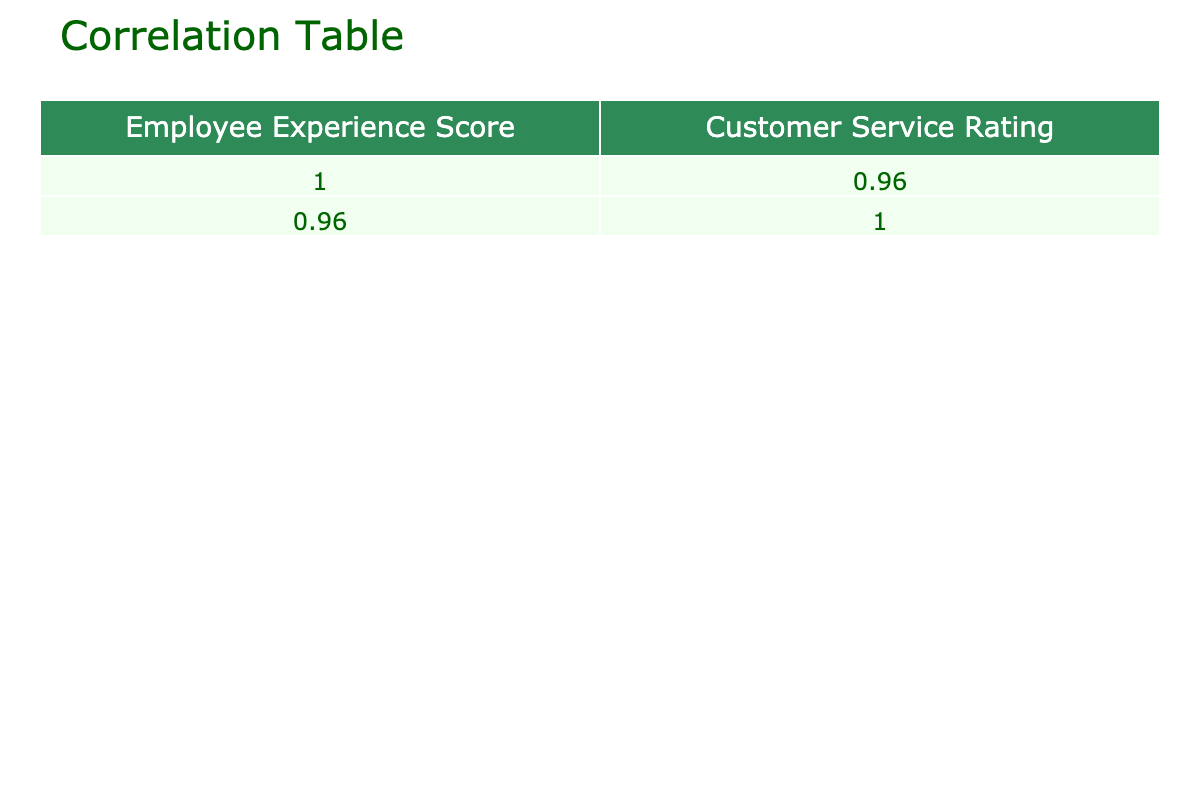What is the correlation coefficient between Employee Experience Score and Customer Service Rating? The correlation coefficient is found in the correlation matrix table. It shows how closely related the two variables are. In this case, the correlation coefficient is 0.93, indicating a very strong positive relationship.
Answer: 0.93 What is the Customer Service Rating for the employee with an Experience Score of 70? We look for 70 in the Employee Experience Score column and find the corresponding Customer Service Rating in the same row. The Customer Service Rating for an Employee Experience Score of 70 is 4.1.
Answer: 4.1 What is the average Employee Experience Score for all employees? To find the average, sum all the Employee Experience Scores (85 + 78 + 90 + 70 + 88 + 75 + 82 + 77 + 80 + 92) =  832 and divide by the number of employees, which is 10. Thus, the average is 832 / 10 = 83.2.
Answer: 83.2 Is there any employee with a Customer Service Rating below 4.5? We check the Customer Service Ratings and see if there are any values less than 4.5. In the table, there is indeed an employee with a Customer Service Rating of 4.1, so the answer is yes.
Answer: Yes What is the difference between the maximum and minimum Customer Service Ratings? First, we identify the maximum Customer Service Rating, which is 5.0, and the minimum, which is 4.1. The difference is calculated as 5.0 - 4.1, which equals 0.9.
Answer: 0.9 What is the average Customer Service Rating for employees with an Experience Score above 85? First, we identify employees with an Experience Score above 85: scores 88, 90, and 92, which correspond to Customer Service Ratings of 4.8, 5.0, and 5.0, respectively. We sum these ratings (4.8 + 5.0 + 5.0 = 14.8) and divide by the number of employees in this group, which is 3. Thus, the average Customer Service Rating is 14.8 / 3 = 4.93.
Answer: 4.93 How many employees have a Customer Service Rating of 4.7 or higher? We examine the Customer Service Ratings in the table and count values that meet or exceed 4.7. The ratings 4.9, 4.5, 5.0, 4.8, 4.7, and 5.0 meet this criterion, leading to a total of 6 employees.
Answer: 6 Is the median Employee Experience Score greater than 80? To find the median, we arrange the Employee Experience Scores in ascending order: 70, 75, 77, 78, 80, 82, 85, 88, 90, 92. With 10 numbers, the median is the average of the 5th and 6th values: (80 + 82) / 2 = 81. Since 81 is greater than 80, the answer is yes.
Answer: Yes 